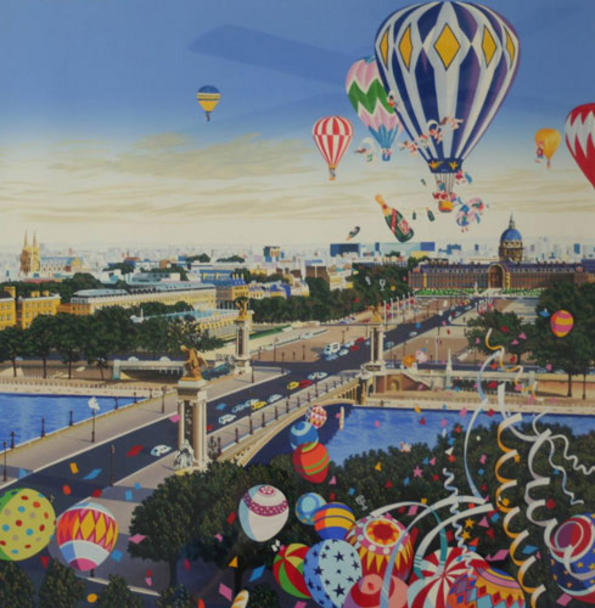Describe a long story of why the city has these hot air balloons, incorporating the fantastic elements of the image. Many years ago, in the heart of this whimsical city, lived a brilliant inventor named Orin who dreamed of creating a magical way to traverse the skies. Inspired by the vibrant colors and creative spirit of his city, Orin designed the first hot air balloon from a mix of enchanted fabrics and innovative engineering. His maiden voyage garnered awe and admiration, leading to a tradition that would transform the city's skyline.

As word spread, the city's artists and craftspeople joined Orin, each contributing their unique flair. They created balloons with fantastical patterns and playful shapes, turning each flight into a celebration of creativity. These balloons soon became symbols of the city's commitment to imagination and innovation, lifting the spirits of all who witnessed their ascent.

The annual festival dedicated to hot air balloons began as a tribute to Orin's legacy. It evolved into a grand event where families and travelers from distant lands gather to share stories, gaze in wonder at the balloon displays, and participate in joyous festivities. The festival's highlight is the Night Glow, where balloons are illuminated, casting an enchanting light across the city, reminiscent of a starlit sky.

Throughout the year, these balloons are more than just a spectacle; they serve practical purposes as well. Balloon taxis provide a unique mode of transport across the city's waterways, while floating markets held in large baskets below the balloons offer an unforgettable shopping experience. The hot air balloons have thus become an integral part of daily life, reflecting the blend of tradition and fantasy that defines the city's identity. 